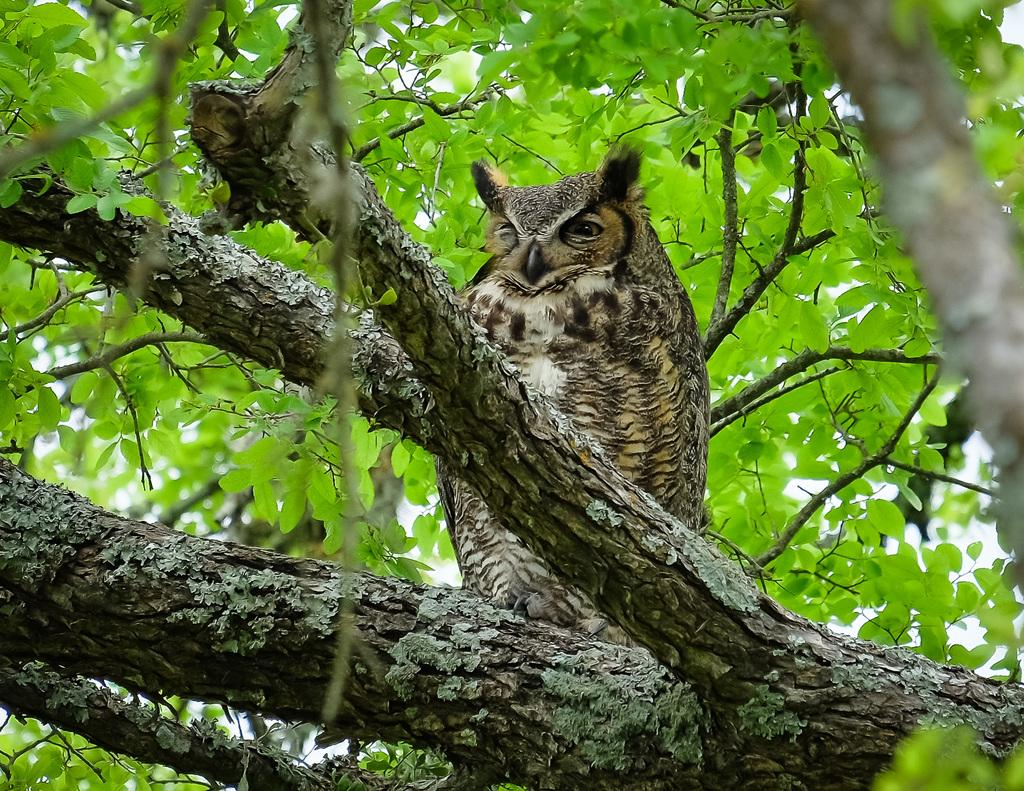What type of creature is in the image? There is an animal in the image. Where is the animal located? The animal is sitting on branches. What can be seen in the background of the image? There are leaves visible in the background of the image. What type of door can be seen in the image? There is no door present in the image; it features an animal sitting on branches with leaves visible in the background. 